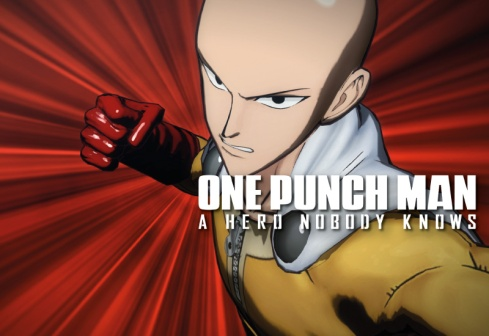Can you elaborate on the elements of the picture provided? The image features the iconic character Saitama from the popular anime and manga series "One Punch Man." Saitama is portrayed in a powerful action pose, his right fist thrust forward with intensity, embodying his incredible strength and capability of defeating opponents with a single punch. He is bald, which is one of his character's distinct traits, and is dressed in his well-known yellow jumpsuit, accentuated with white gloves and boots, and a flowing red cape that suggests motion and energy. The dynamic background features a striking radial gradient from black at the center to a vivid red at the edges, highlighting the dramatic essence of the scene. This dramatic backdrop accentuates the heroism and power of Saitama, while the title "One Punch Man" is prominently displayed in bold white text in the top right corner, with the subtitle "A hero nobody knows" below it. This image captures the spirit and dynamism of Saitama, making it a compelling representation of the character and the series. 